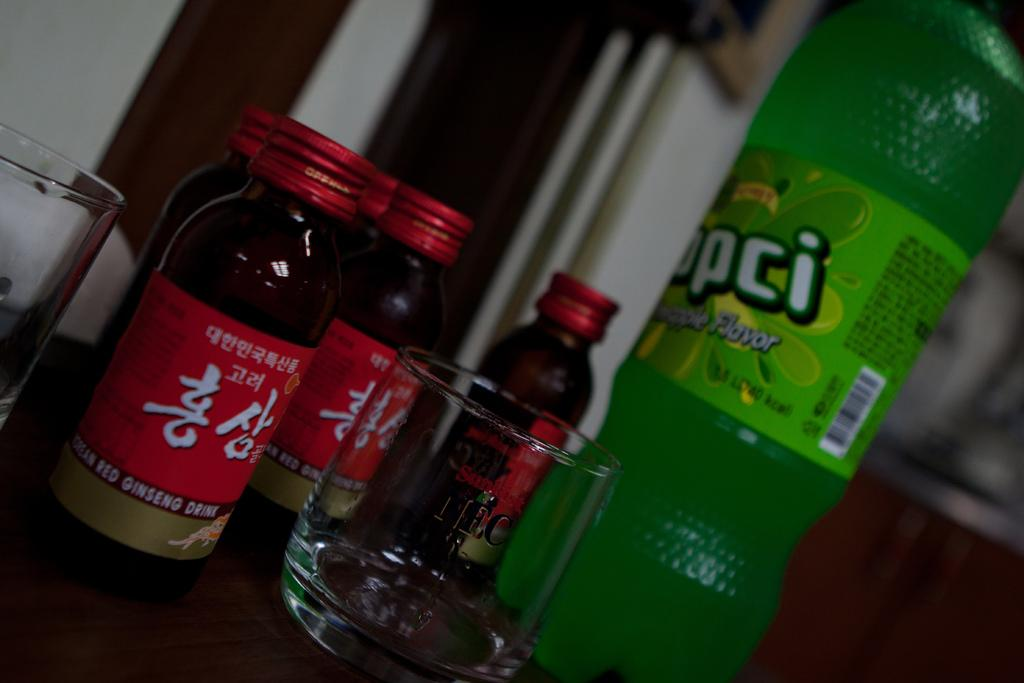<image>
Share a concise interpretation of the image provided. some bottles of KOREAN RED GINSENG DRINK, a small Sunkist glass and a green bottle of another drink. 